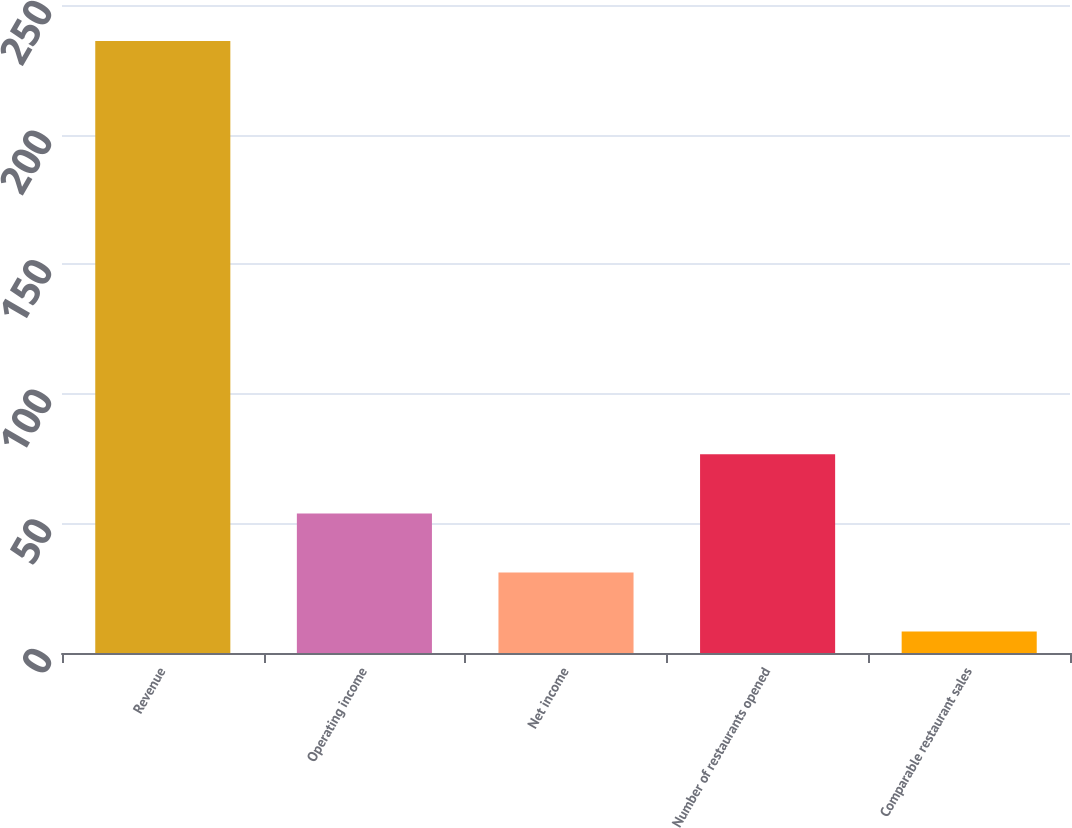Convert chart. <chart><loc_0><loc_0><loc_500><loc_500><bar_chart><fcel>Revenue<fcel>Operating income<fcel>Net income<fcel>Number of restaurants opened<fcel>Comparable restaurant sales<nl><fcel>236.1<fcel>53.86<fcel>31.08<fcel>76.64<fcel>8.3<nl></chart> 